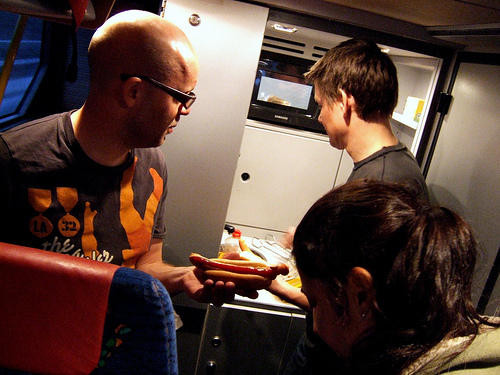<image>
Is there a hot dog behind the man? No. The hot dog is not behind the man. From this viewpoint, the hot dog appears to be positioned elsewhere in the scene. 